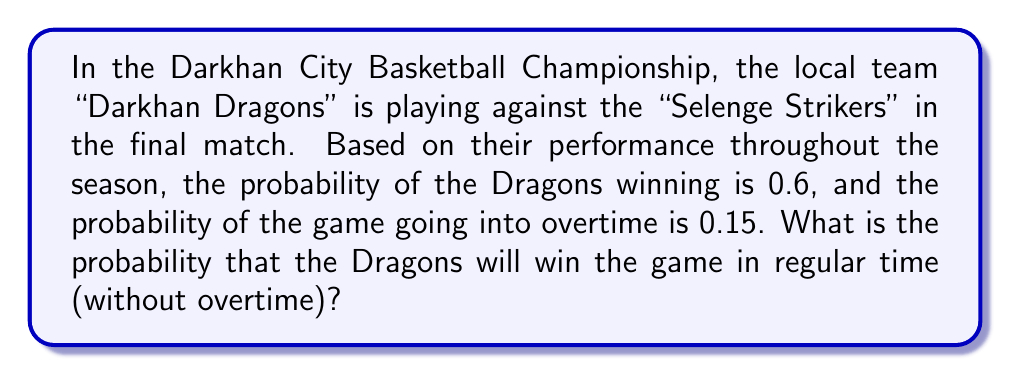Could you help me with this problem? Let's approach this step-by-step using the concepts of probability:

1) First, let's define our events:
   A: Dragons win the game
   B: The game goes into overtime

2) We're given:
   $P(A) = 0.6$ (probability of Dragons winning)
   $P(B) = 0.15$ (probability of the game going into overtime)

3) We need to find the probability of Dragons winning in regular time. This can be expressed as:
   Dragons win AND the game doesn't go into overtime

4) In probability terms, this is:
   $P(A \cap B')$, where $B'$ is the complement of B (game doesn't go into overtime)

5) We can calculate this using the formula:
   $P(A \cap B') = P(A) - P(A \cap B)$

6) We know $P(A)$, but we need to find $P(A \cap B)$

7) Assuming that the probability of winning in overtime is the same as winning overall:
   $P(A \cap B) = P(A) \times P(B) = 0.6 \times 0.15 = 0.09$

8) Now we can calculate:
   $P(A \cap B') = P(A) - P(A \cap B)$
   $P(A \cap B') = 0.6 - 0.09 = 0.51$

Therefore, the probability of the Dragons winning in regular time is 0.51 or 51%.
Answer: 0.51 or 51% 